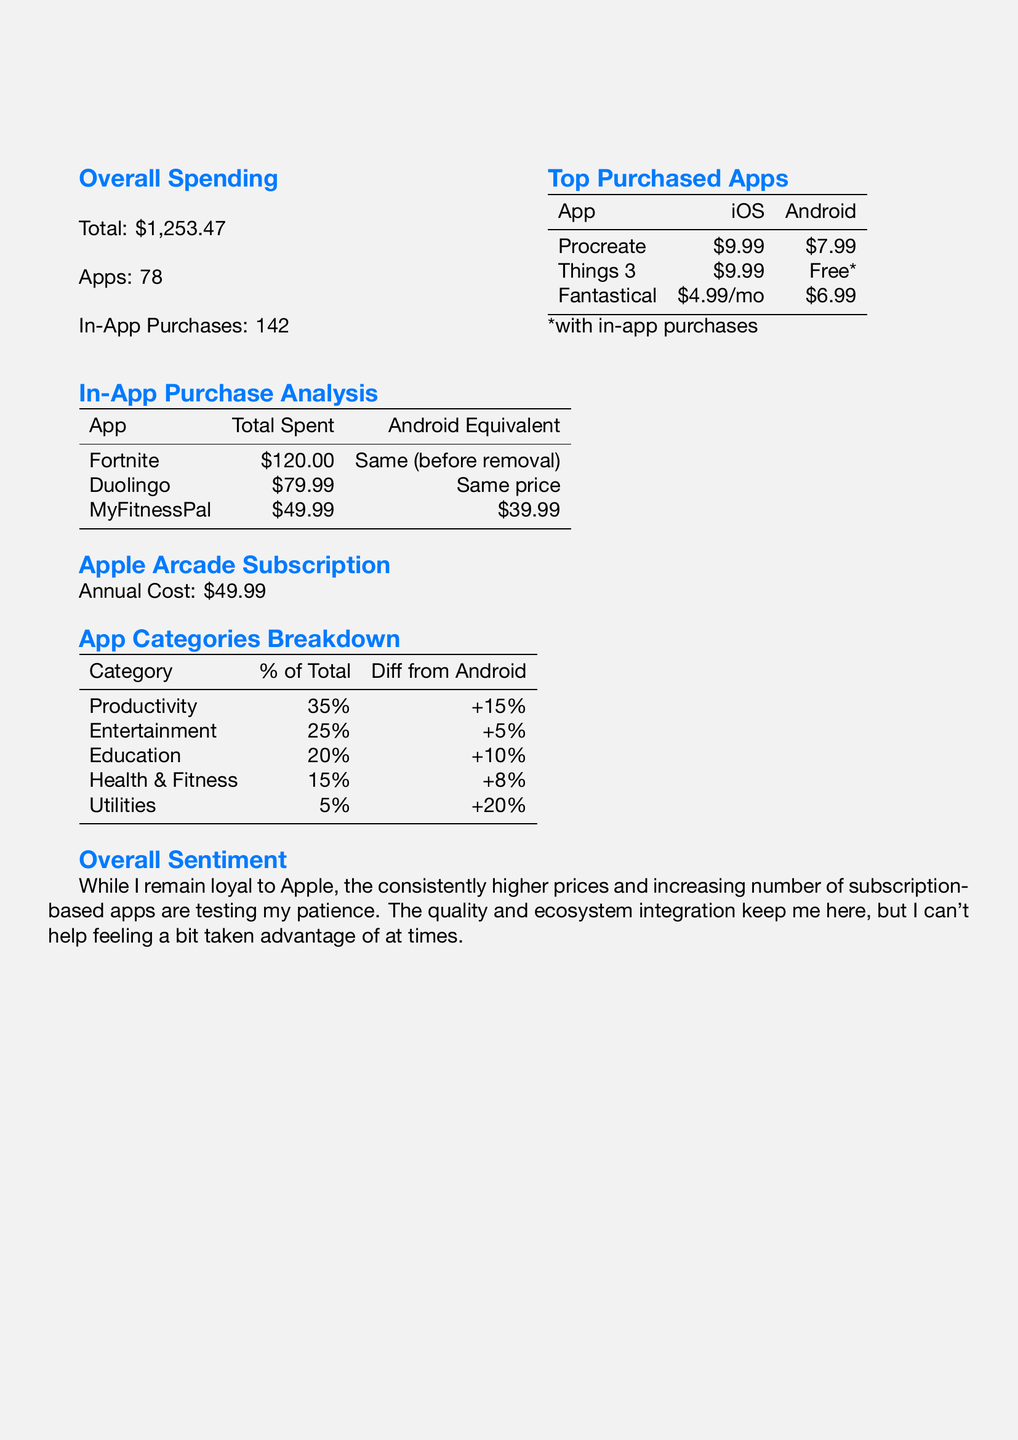what is the total amount spent on the App Store? The total amount spent is listed under the overall spending section, which is $1,253.47.
Answer: $1,253.47 how many in-app purchases were made? The number of in-app purchases is specified in the overall spending section, which states there were 142 purchases.
Answer: 142 what is the price of Procreate in the App Store? The price of Procreate is mentioned in the top purchased apps section, which is $9.99.
Answer: $9.99 what is the Android equivalent of Things 3? The Android equivalent of Things 3 is listed as Todoist in the top purchased apps section.
Answer: Todoist which app category had the highest percentage of total spend? The highest percentage of total spend is mentioned in the app categories breakdown, which is Productivity at 35%.
Answer: Productivity what is the average price difference for the Productivity category compared to Android? The average price difference for the Productivity category is indicated as +15% in the app categories breakdown.
Answer: +15% what subscription model is used for Fantastical? The subscription model for Fantastical is described in the top purchased apps section as a monthly subscription for $4.99.
Answer: monthly subscription what was the annual cost for the Apple Arcade subscription? The annual cost for the Apple Arcade subscription is detailed in the Apple Arcade subscription section, which is $49.99.
Answer: $49.99 how much was spent on Duolingo? The total spent on Duolingo is mentioned in the in-app purchase analysis as $79.99.
Answer: $79.99 